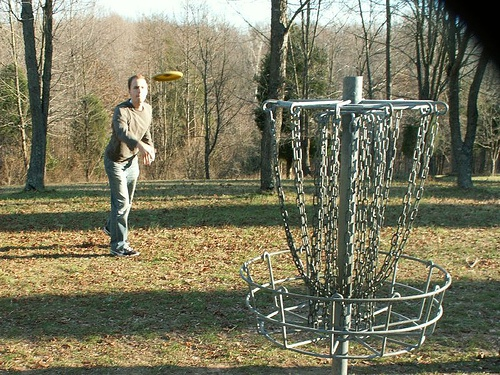Describe the objects in this image and their specific colors. I can see people in gray, beige, black, and tan tones and frisbee in gray, olive, and khaki tones in this image. 